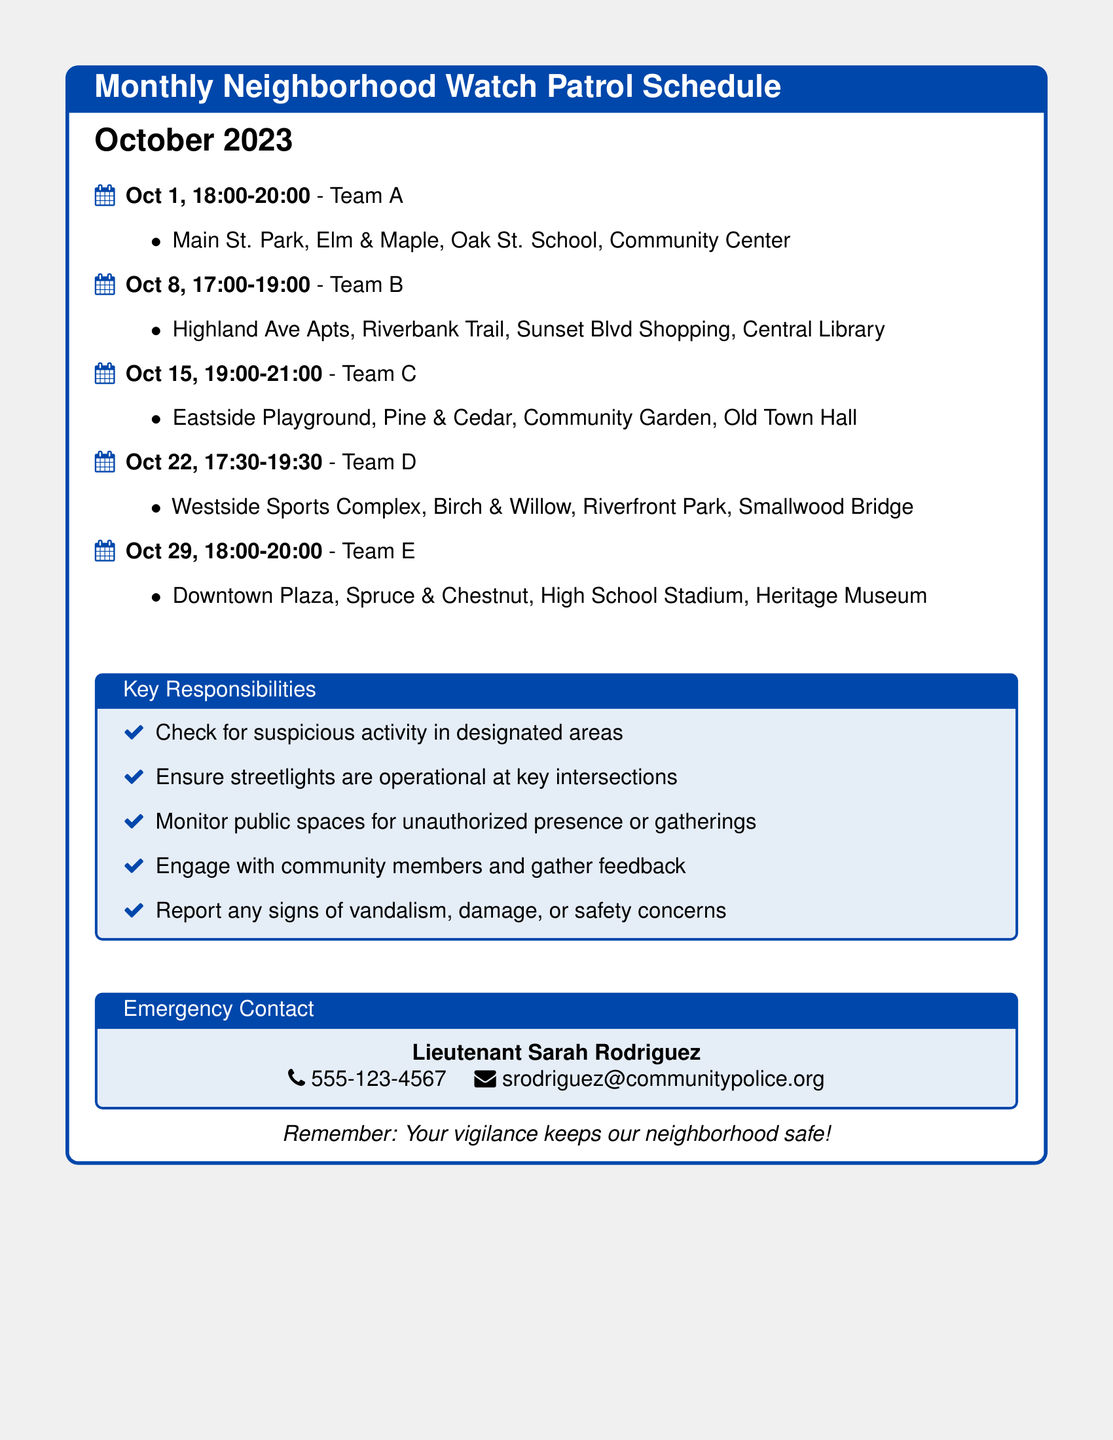What is the date of the first patrol? The first patrol is scheduled for October 1st, 2023.
Answer: October 1 Who is the contact person for emergencies? The document lists Lieutenant Sarah Rodriguez as the emergency contact.
Answer: Sarah Rodriguez What time does Team B start their patrol? Team B's patrol begins at 5:00 PM on October 8th.
Answer: 17:00 Which team is assigned to the Downtown Plaza? The Downtown Plaza is monitored by Team E according to the schedule.
Answer: Team E How many patrols are scheduled in October? The total number of patrols listed in the schedule is five for October.
Answer: 5 What is one of the key responsibilities of the patrol teams? The document indicates that a key responsibility includes checking for suspicious activity.
Answer: Check for suspicious activity What area is Team D patrolling? The areas assigned to Team D include Westside Sports Complex and Birch & Willow.
Answer: Westside Sports Complex, Birch & Willow What time does the last patrol end? The last patrol on October 29th concludes at 8:00 PM.
Answer: 20:00 